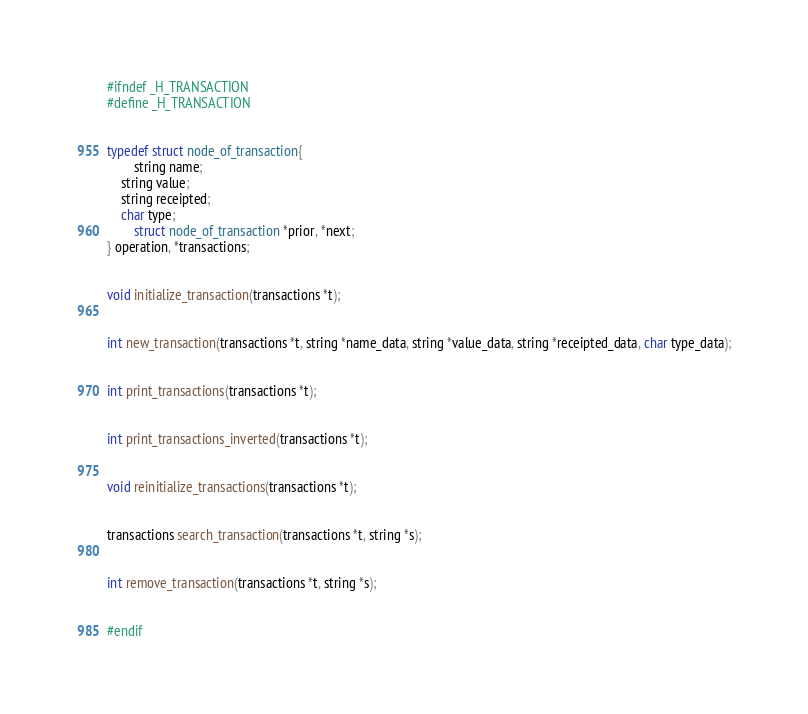Convert code to text. <code><loc_0><loc_0><loc_500><loc_500><_C_>#ifndef _H_TRANSACTION
#define _H_TRANSACTION


typedef struct node_of_transaction{
        string name;
	string value;
	string receipted;
	char type;
        struct node_of_transaction *prior, *next;
} operation, *transactions;


void initialize_transaction(transactions *t);


int new_transaction(transactions *t, string *name_data, string *value_data, string *receipted_data, char type_data);


int print_transactions(transactions *t);


int print_transactions_inverted(transactions *t);


void reinitialize_transactions(transactions *t);


transactions search_transaction(transactions *t, string *s);


int remove_transaction(transactions *t, string *s);


#endif


</code> 